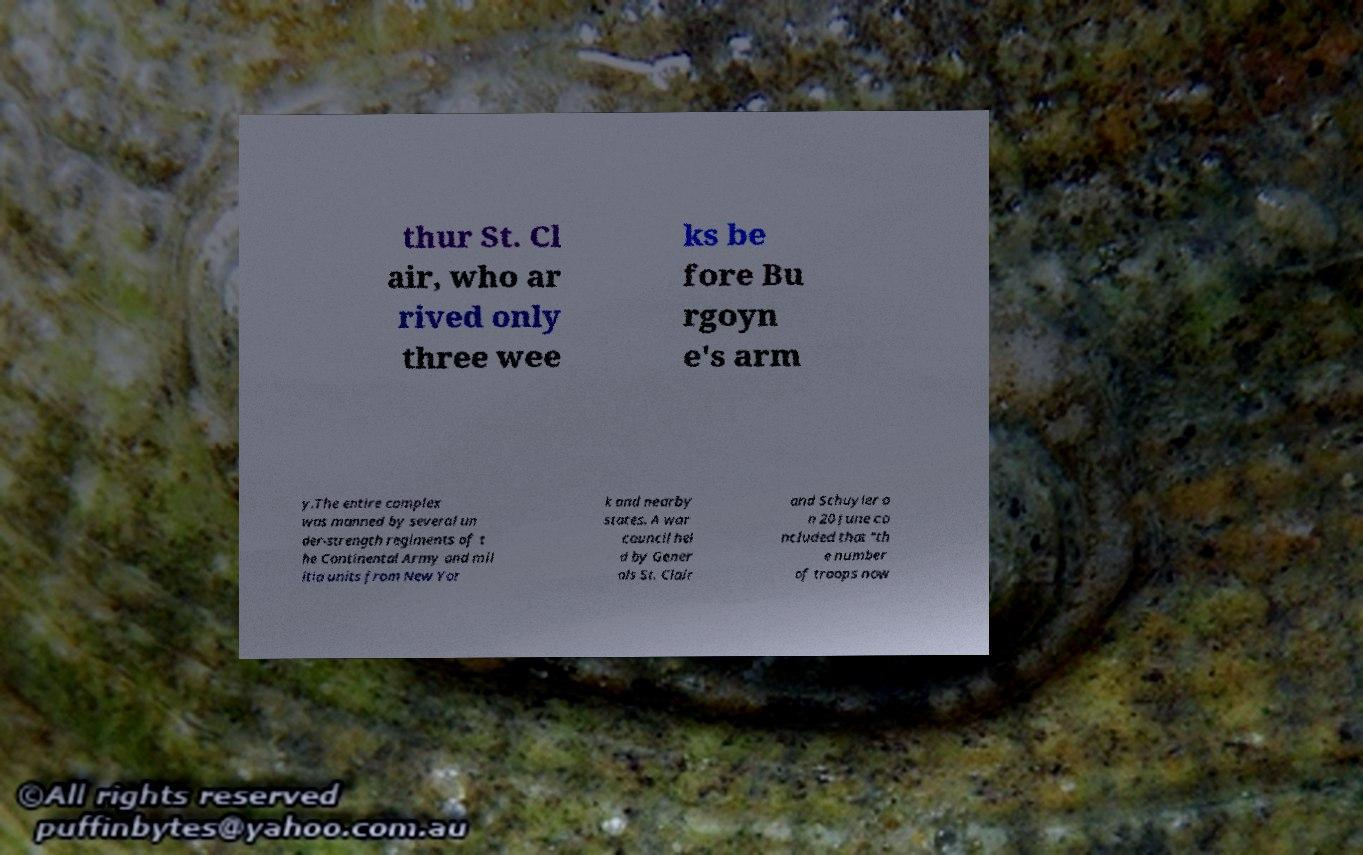Can you accurately transcribe the text from the provided image for me? thur St. Cl air, who ar rived only three wee ks be fore Bu rgoyn e's arm y.The entire complex was manned by several un der-strength regiments of t he Continental Army and mil itia units from New Yor k and nearby states. A war council hel d by Gener als St. Clair and Schuyler o n 20 June co ncluded that "th e number of troops now 